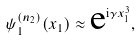<formula> <loc_0><loc_0><loc_500><loc_500>\psi _ { 1 } ^ { ( n _ { 2 } ) } ( x _ { 1 } ) \approx \text {e} ^ { \text {i} \gamma x _ { 1 } ^ { 3 } } ,</formula> 